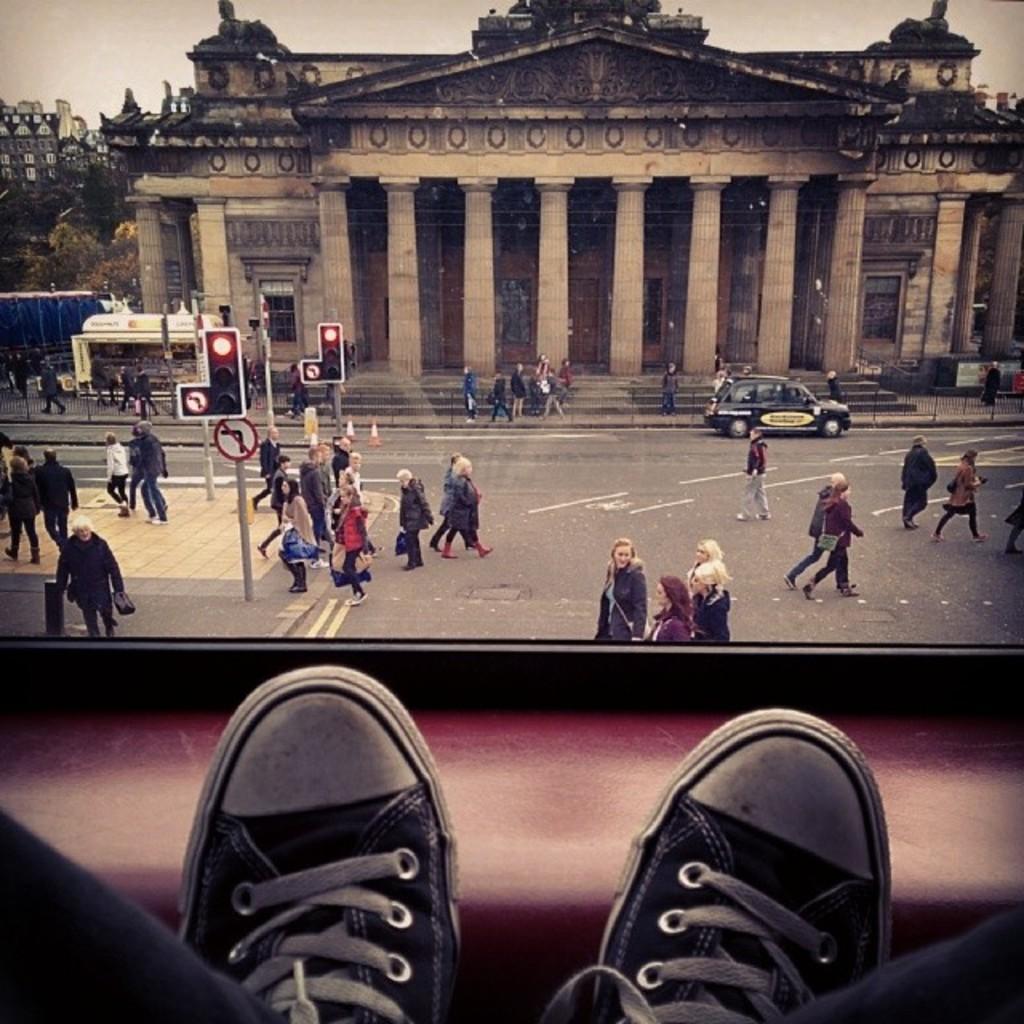In one or two sentences, can you explain what this image depicts? We can see footwear and there are people walking. We can see boards on poles and car on the road. In the background we can see buildings,pillars,trees and sky. 